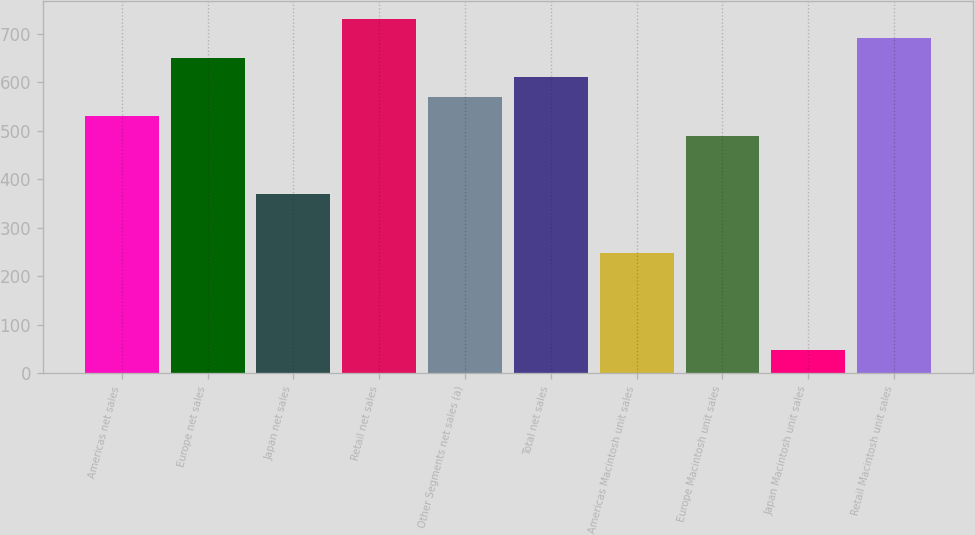Convert chart. <chart><loc_0><loc_0><loc_500><loc_500><bar_chart><fcel>Americas net sales<fcel>Europe net sales<fcel>Japan net sales<fcel>Retail net sales<fcel>Other Segments net sales (a)<fcel>Total net sales<fcel>Americas Macintosh unit sales<fcel>Europe Macintosh unit sales<fcel>Japan Macintosh unit sales<fcel>Retail Macintosh unit sales<nl><fcel>529.6<fcel>650.2<fcel>368.8<fcel>730.6<fcel>569.8<fcel>610<fcel>248.2<fcel>489.4<fcel>47.2<fcel>690.4<nl></chart> 